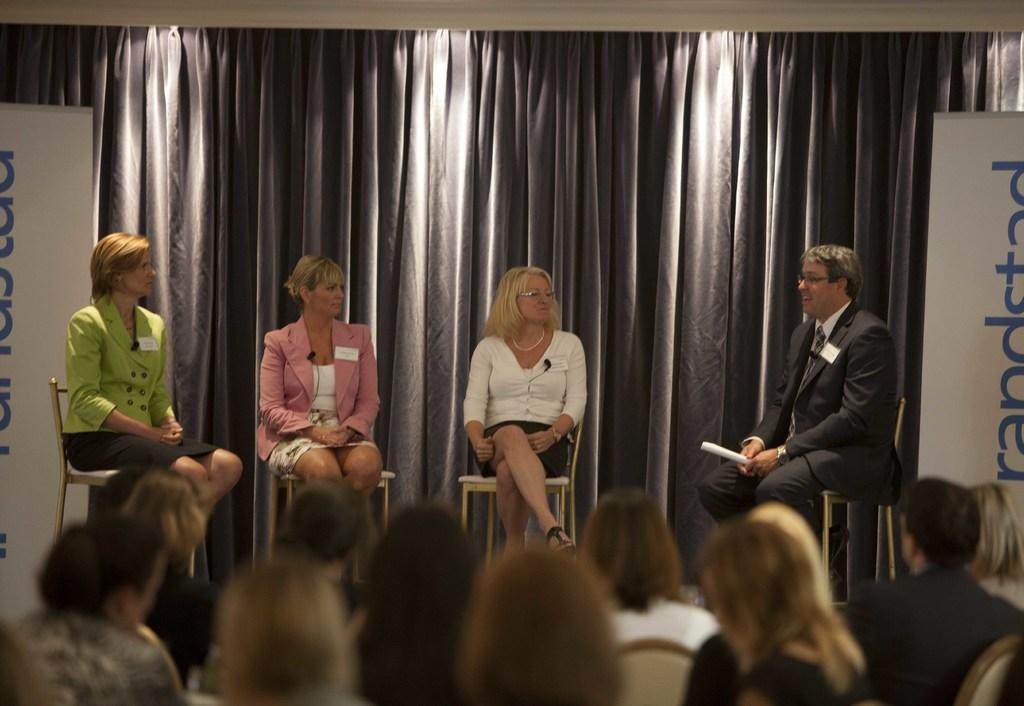How many people are sitting on chairs in the image? There are four persons sitting on chairs in the image. What is one of the persons doing with their hands? One of the persons is holding a paper. Can you describe the people visible in the image? There are people visible in the image, but the conversation does not specify their actions or characteristics. What type of decorative elements can be seen in the image? There are banners in the image. What can be seen in the background of the image? There are curtains in the background of the image. How much money is on the table in the image? There is no mention of money or a table in the image, so it cannot be determined. Can you tell me how many chickens are visible in the image? There are no chickens present in the image. 